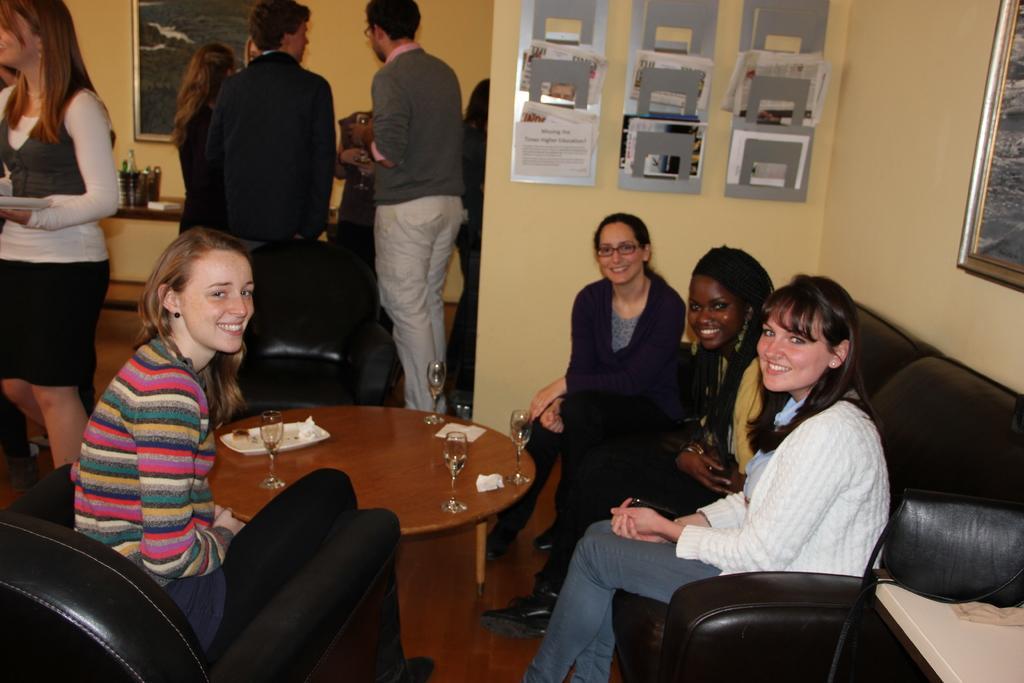Can you describe this image briefly? This image is clicked inside the room. There are many people in this image. In the front, there are four persons sitting in a black sofa. In the background, there is a wall on which frame and papers stands are fixed. To the left, the woman is wearing white dress. 